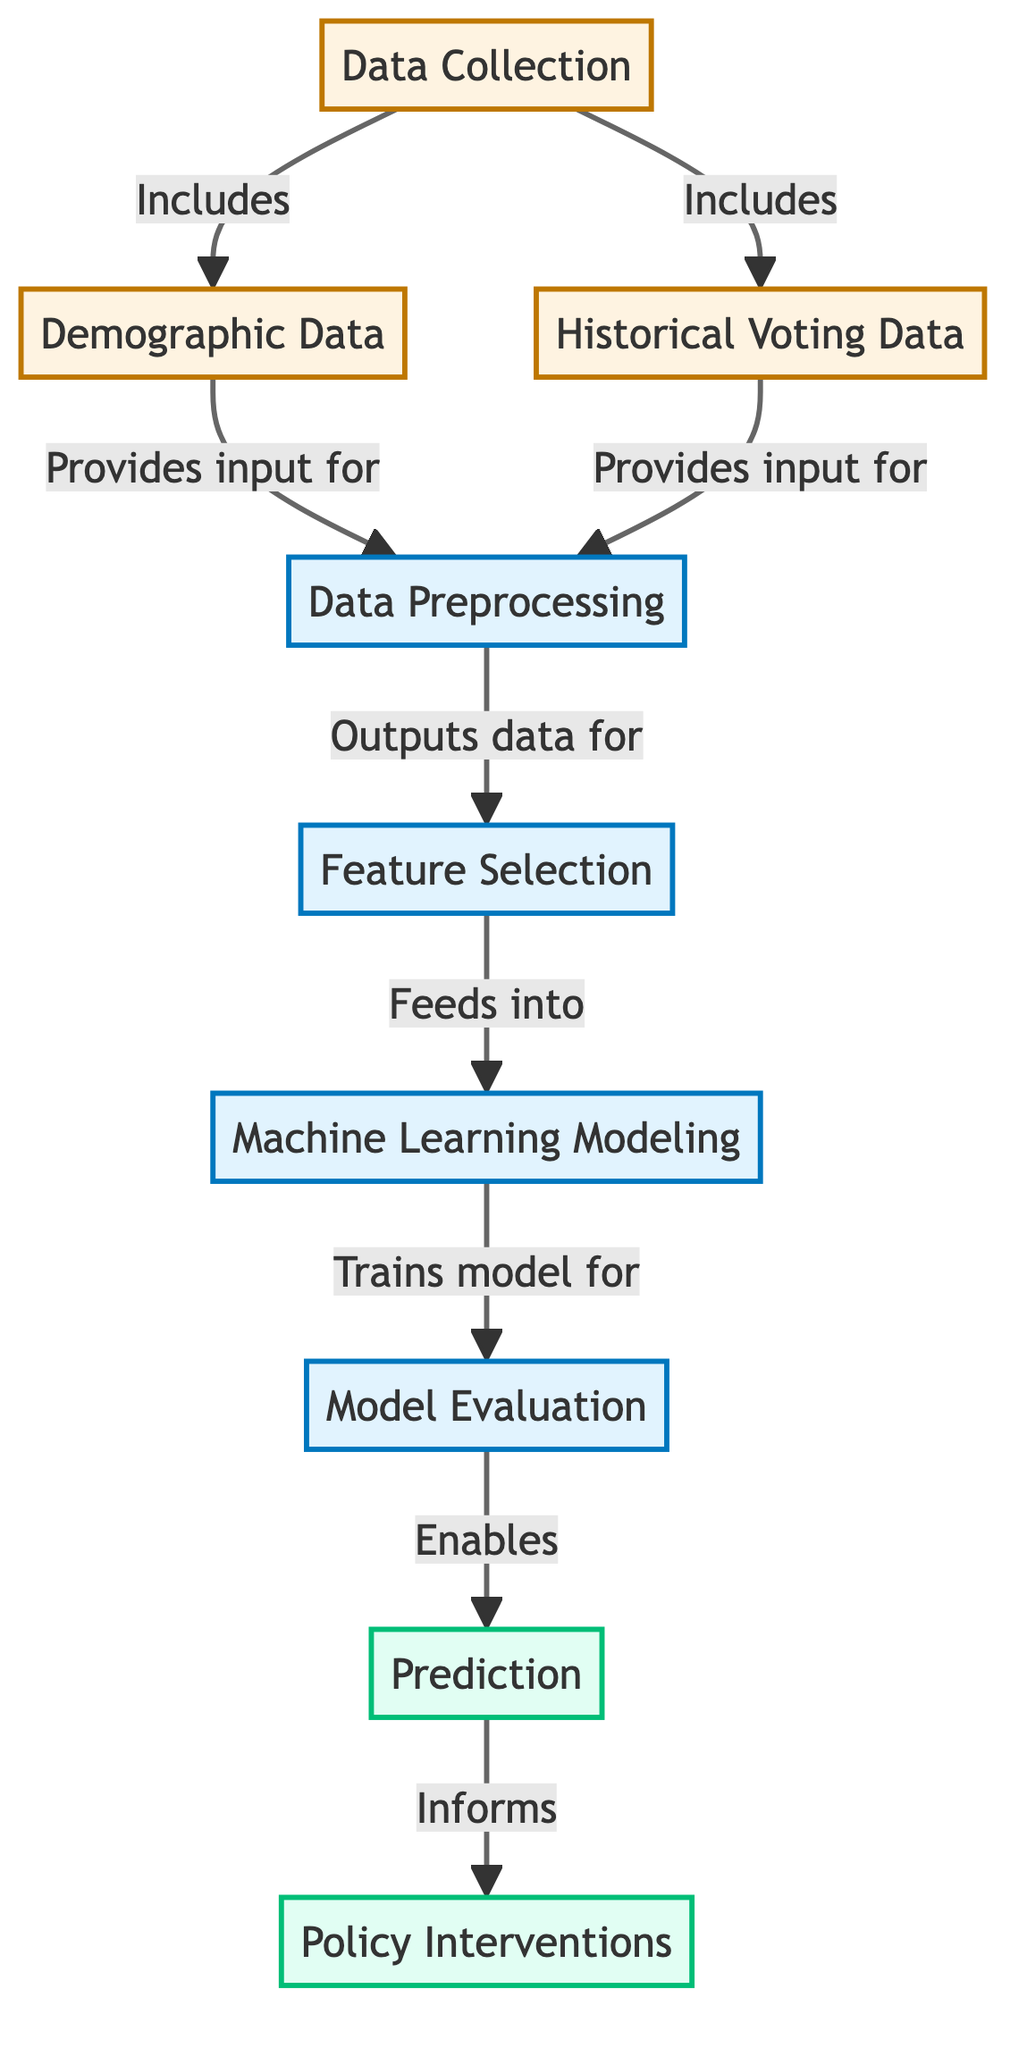What are the two main data sources in the diagram? The diagram identifies two primary data sources: "Demographic Data" and "Historical Voting Data," which feed into the "Data Collection" node.
Answer: Demographic Data and Historical Voting Data How many processing steps are there in the diagram? The diagram outlines three distinct processing steps: "Data Preprocessing," "Feature Selection," and "Machine Learning Modeling." Counting these nodes gives a total of three.
Answer: Three Which node directly informs "Policy Interventions"? The "Prediction" node directly informs "Policy Interventions," as indicated by the arrow pointing from "Prediction" to "Policy Interventions."
Answer: Prediction What is the output of the "Model Evaluation" node? The "Model Evaluation" node enables the "Prediction" node, meaning it serves as an input to the prediction process, illustrating its role in assessing the model's performance before making predictions.
Answer: Prediction What comes after "Feature Selection" in the flow? Following "Feature Selection," the next step in the flow is "Machine Learning Modeling," which uses the outcomes from the feature selection process for building the model.
Answer: Machine Learning Modeling What is the relationship between "Data Collection" and "Demographic Data"? "Data Collection" includes "Demographic Data," which means that the demographic information is a part of the broader data collection process and contributes to data preparation and analysis.
Answer: Includes How many output nodes are shown in the diagram? The diagram illustrates two output nodes: "Prediction" and "Policy Interventions," indicating the final outputs after the modeling and evaluation phases.
Answer: Two Which node feeds data into "Data Preprocessing"? Both "Demographic Data" and "Historical Voting Data" feed into "Data Preprocessing," as mentioned in the connections from these nodes to the preprocessing step.
Answer: Demographic Data and Historical Voting Data What is the role of "Feature Selection" in the diagram? The role of "Feature Selection" is to refine the input data before it is used in "Machine Learning Modeling" by determining which features should be used for training the model based on their relevance.
Answer: Refine input data 